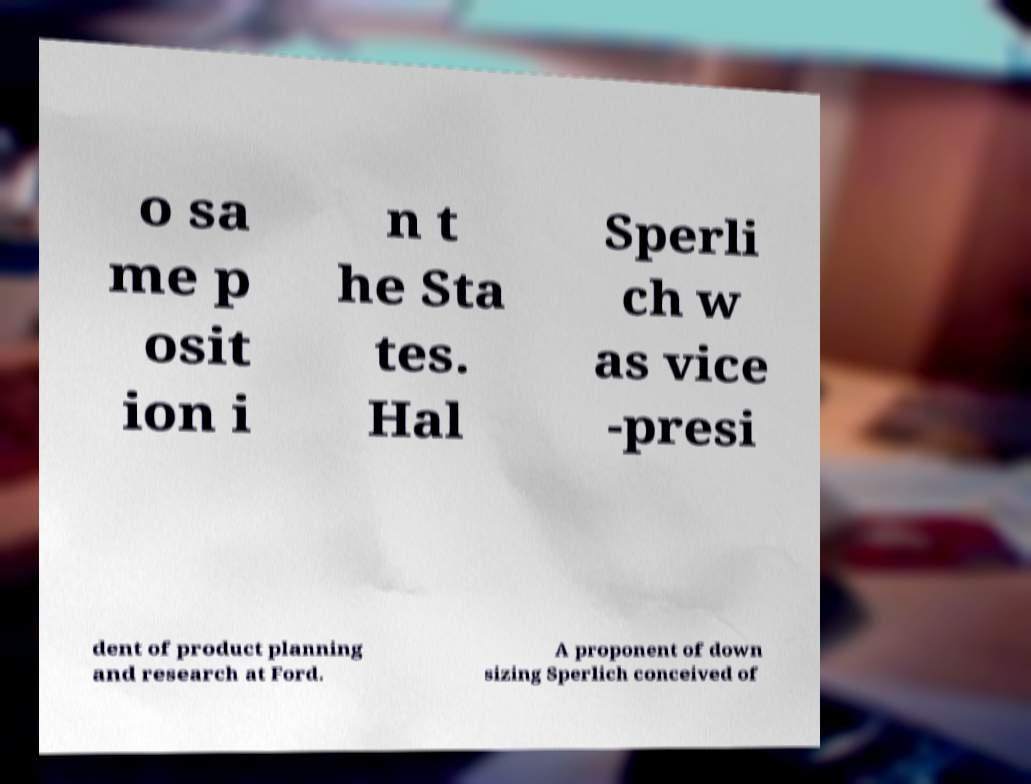Could you assist in decoding the text presented in this image and type it out clearly? o sa me p osit ion i n t he Sta tes. Hal Sperli ch w as vice -presi dent of product planning and research at Ford. A proponent of down sizing Sperlich conceived of 